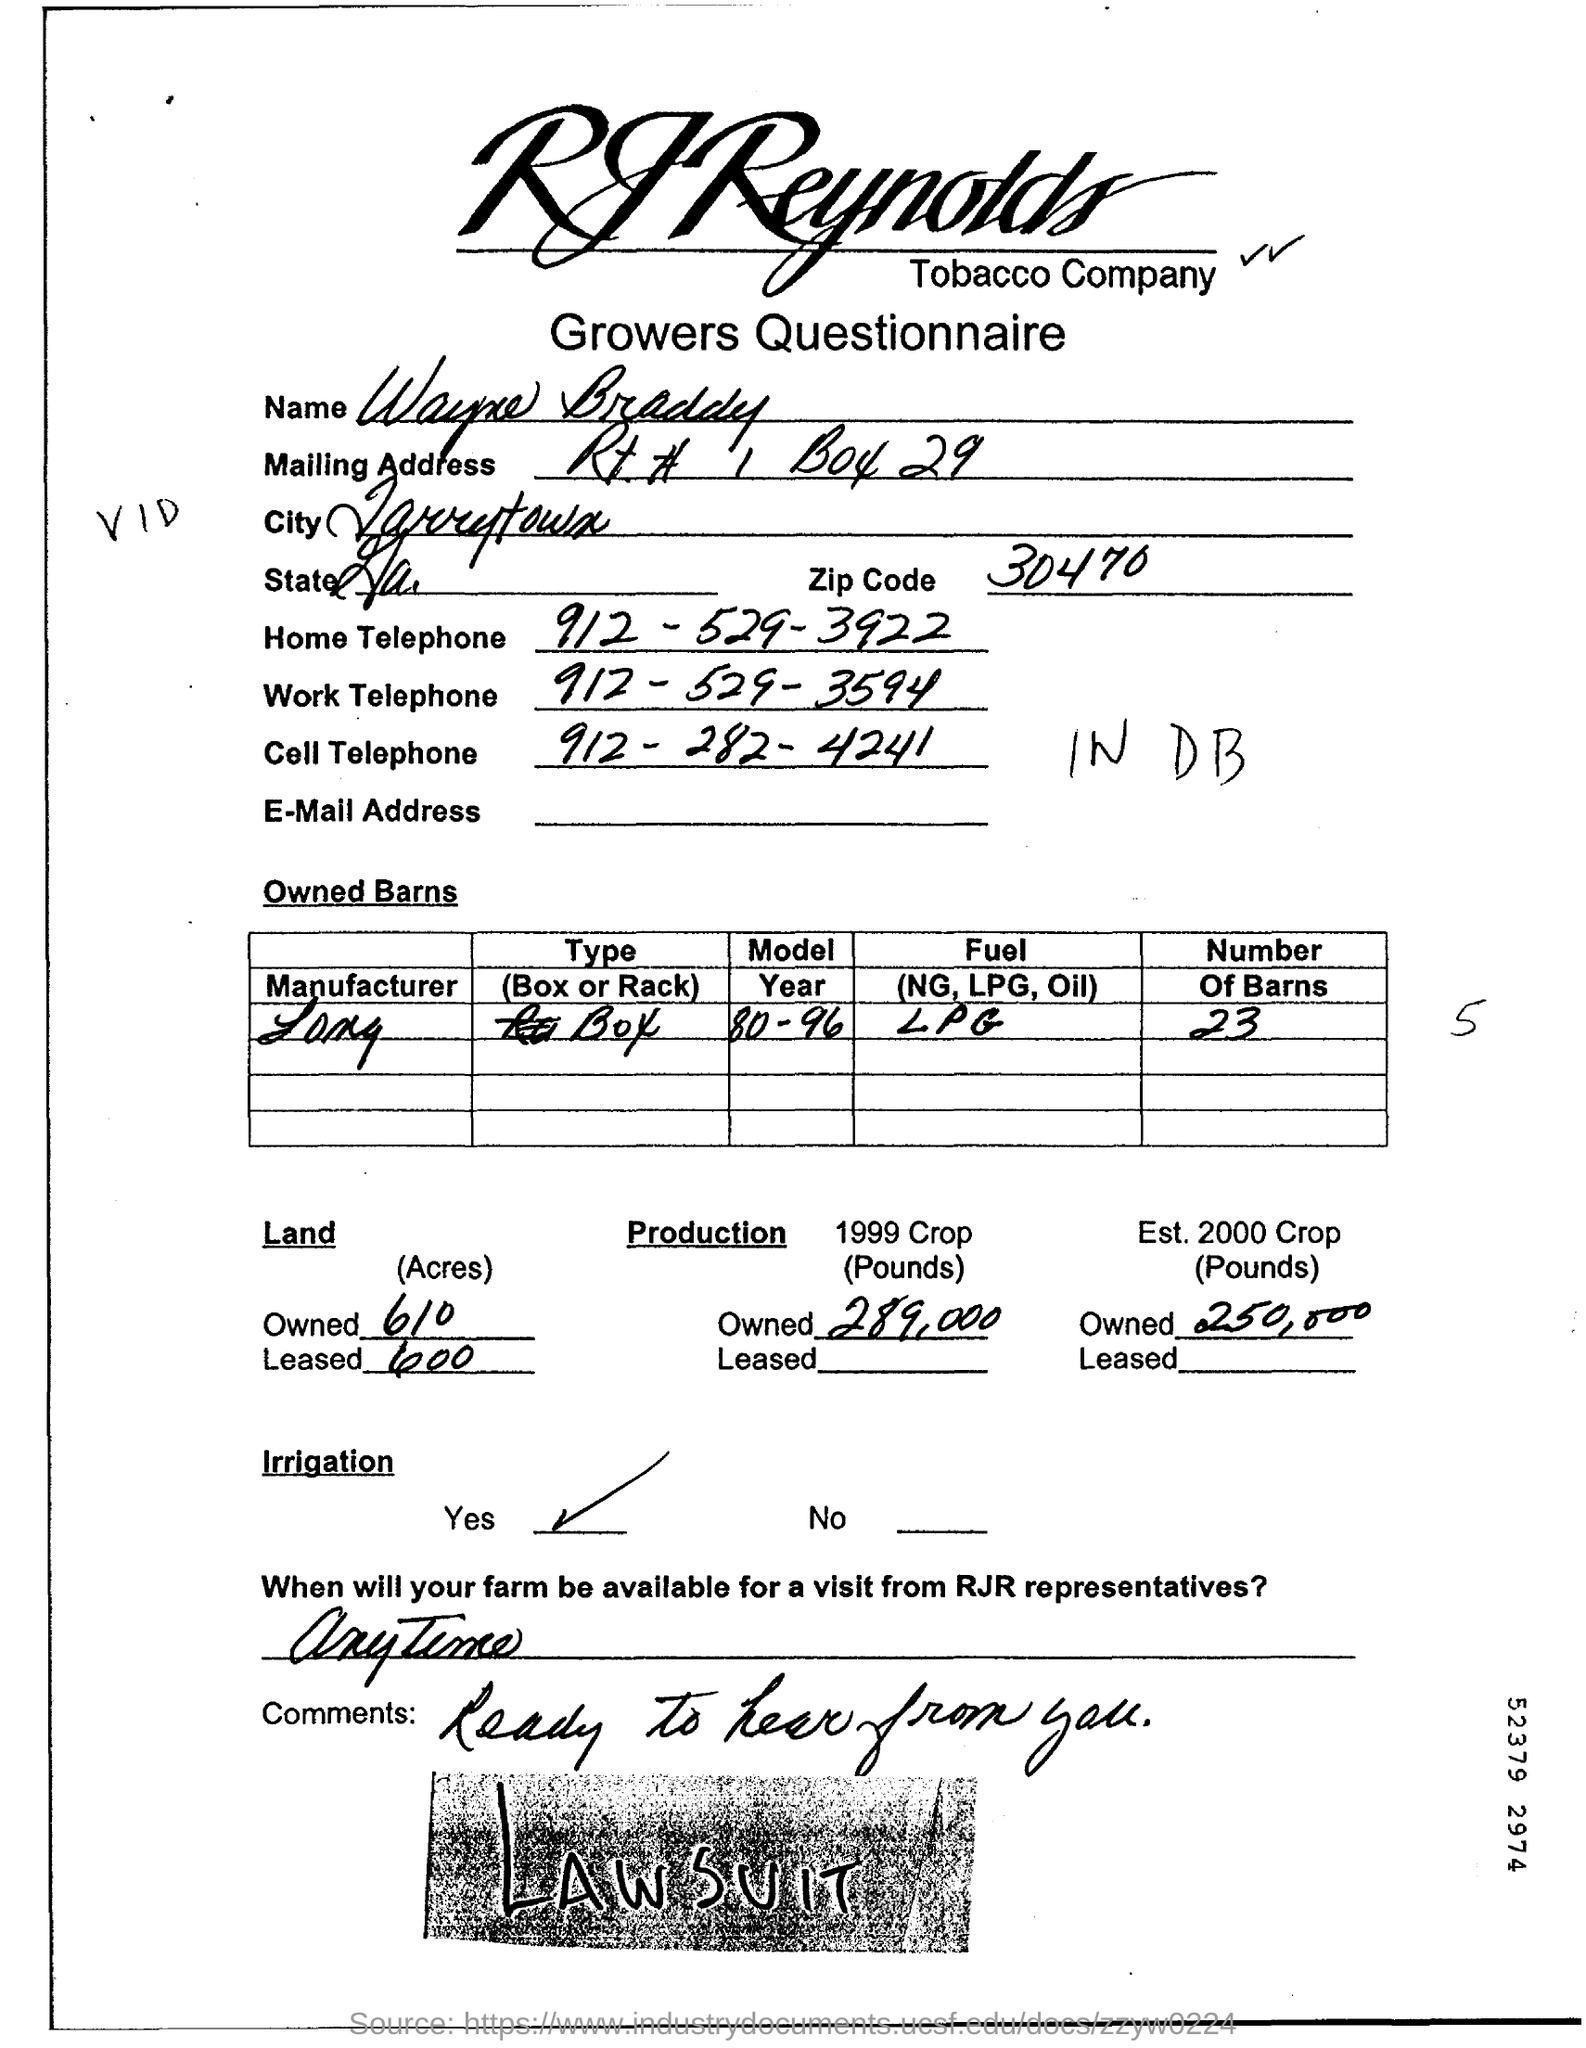Outline some significant characteristics in this image. The zip code is 30470. The individual provided their home telephone number as 912-529-3922. 